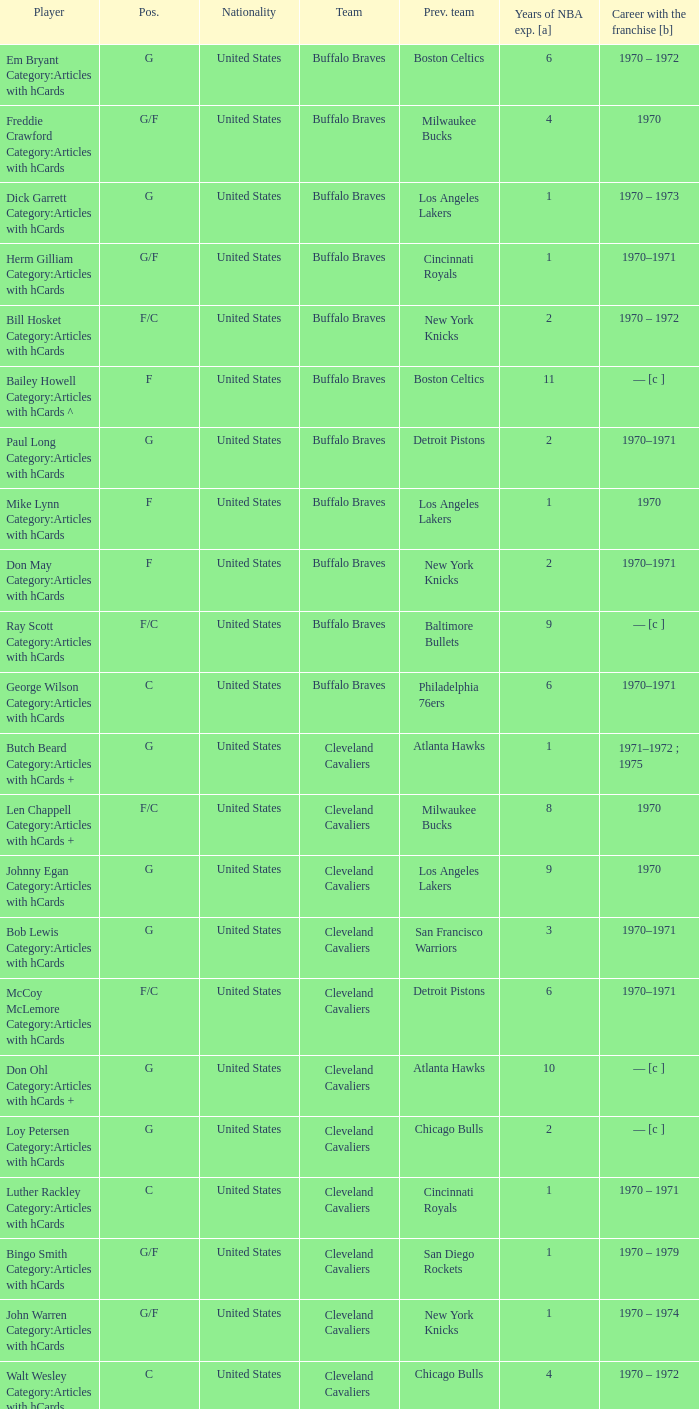Who is the player from the Buffalo Braves with the previous team Los Angeles Lakers and a career with the franchase in 1970? Mike Lynn Category:Articles with hCards. 